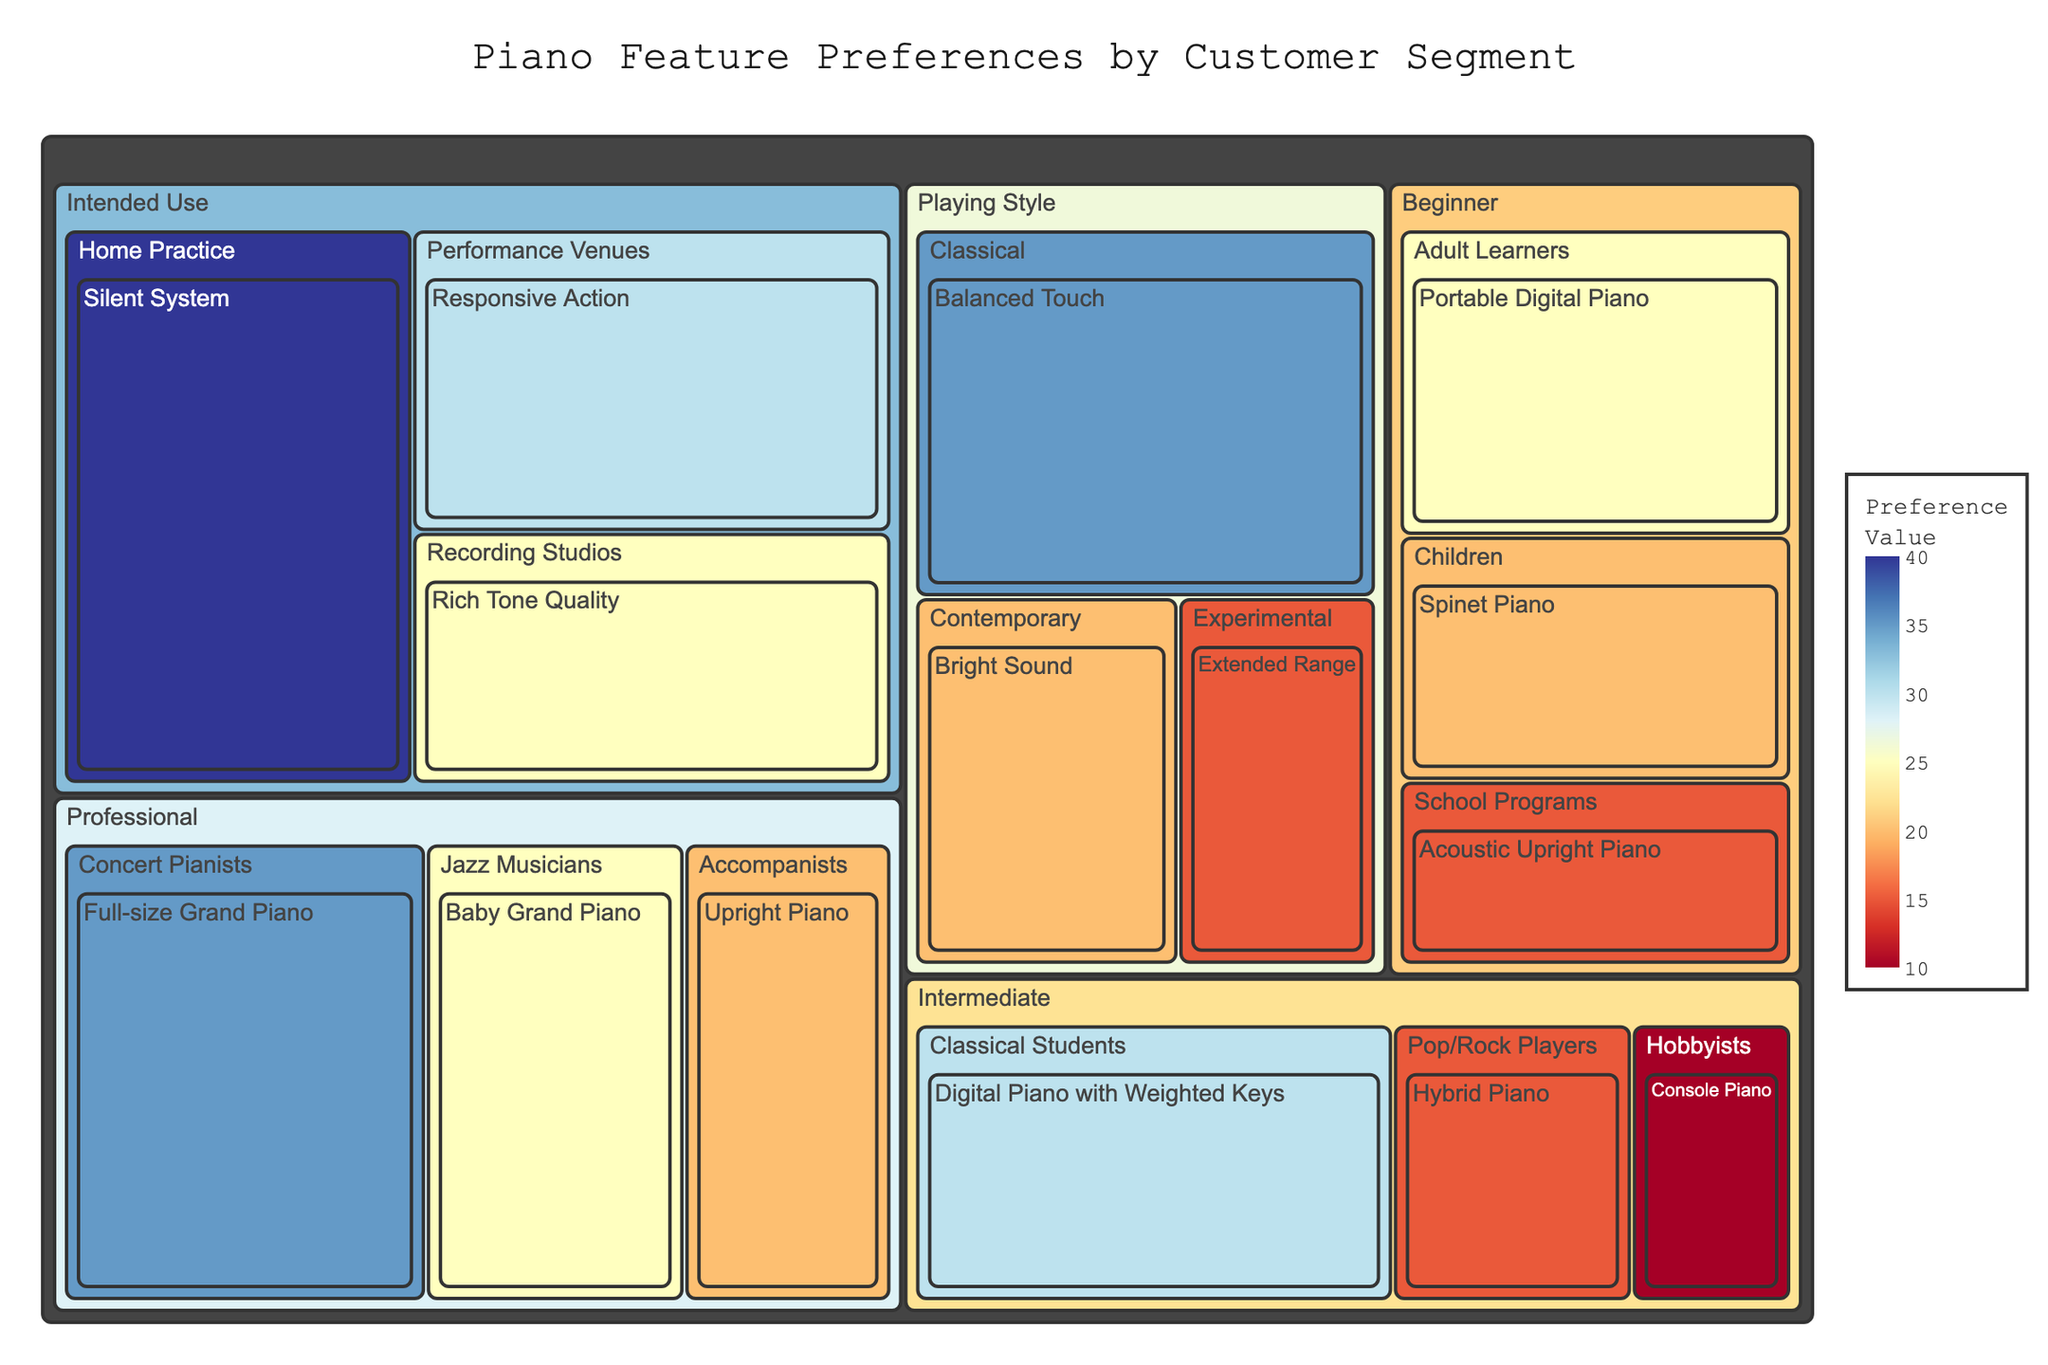What is the most preferred piano feature in the "Professional" category? Look at the segments within the "Professional" category and compare their values. The feature with the highest value is the most preferred.
Answer: Full-size Grand Piano Which subcategory within the "Intermediate" category prefers the Hybrid Piano? Locate the "Intermediate" category and check the subcategories. Find the subcategory associated with the Hybrid Piano.
Answer: Pop/Rock Players How many features are preferred by the "Beginner" category? Count the total number of features listed under the "Beginner" category.
Answer: 3 Which segment prefers pianos with the "Silent System" feature, and what is the value? Identify the segment where the "Silent System" feature is located and read its value.
Answer: Home Practice, 40 Compare the values for "Rich Tone Quality" in Recording Studios and "Balanced Touch" in Classical playing style. Which one has a higher preference? Find the value for "Rich Tone Quality" under Recording Studios and "Balanced Touch" under Classical playing style, then compare them.
Answer: Balanced Touch What is the least preferred feature in the "Playing Style" category? Observe the segment for "Playing Style" and identify the feature with the smallest value.
Answer: Extended Range What is the combined preference value for all features within the "Intended Use" category? Sum up the values for all features under the "Intended Use" category. The values are 40, 30, and 25. 40 + 30 + 25 = 95.
Answer: 95 Which category has the highest total preference value, and what is that value? Sum the values within each category and compare them. 
* Professional: 35 + 25 + 20 = 80
* Intermediate: 30 + 15 + 10 = 55
* Beginner: 20 + 25 + 15 = 60
* Intended Use: 40 + 30 + 25 = 95
* Playing Style: 35 + 20 + 15 = 70 
Intended Use has the highest total preference value of 95.
Answer: Intended Use, 95 Which feature is preferred by "Adult Learners" and what is the preference value? Locate the "Adult Learners" subcategory within the "Beginner" category and identify its corresponding preference value.
Answer: Portable Digital Piano, 25 For "Jazz Musicians," how does the preference for Baby Grand Piano compare to the preference for Upright Piano by "Accompanists"? Locate and compare the values for Baby Grand Piano under Jazz Musicians and Upright Piano under Accompanists in the Professional category. 25 (Baby Grand Piano) vs. 20 (Upright Piano). 25 is greater than 20.
Answer: Baby Grand Piano is preferred more 